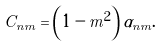Convert formula to latex. <formula><loc_0><loc_0><loc_500><loc_500>C _ { n m } = \left ( 1 - m ^ { 2 } \right ) \alpha _ { n m } .</formula> 